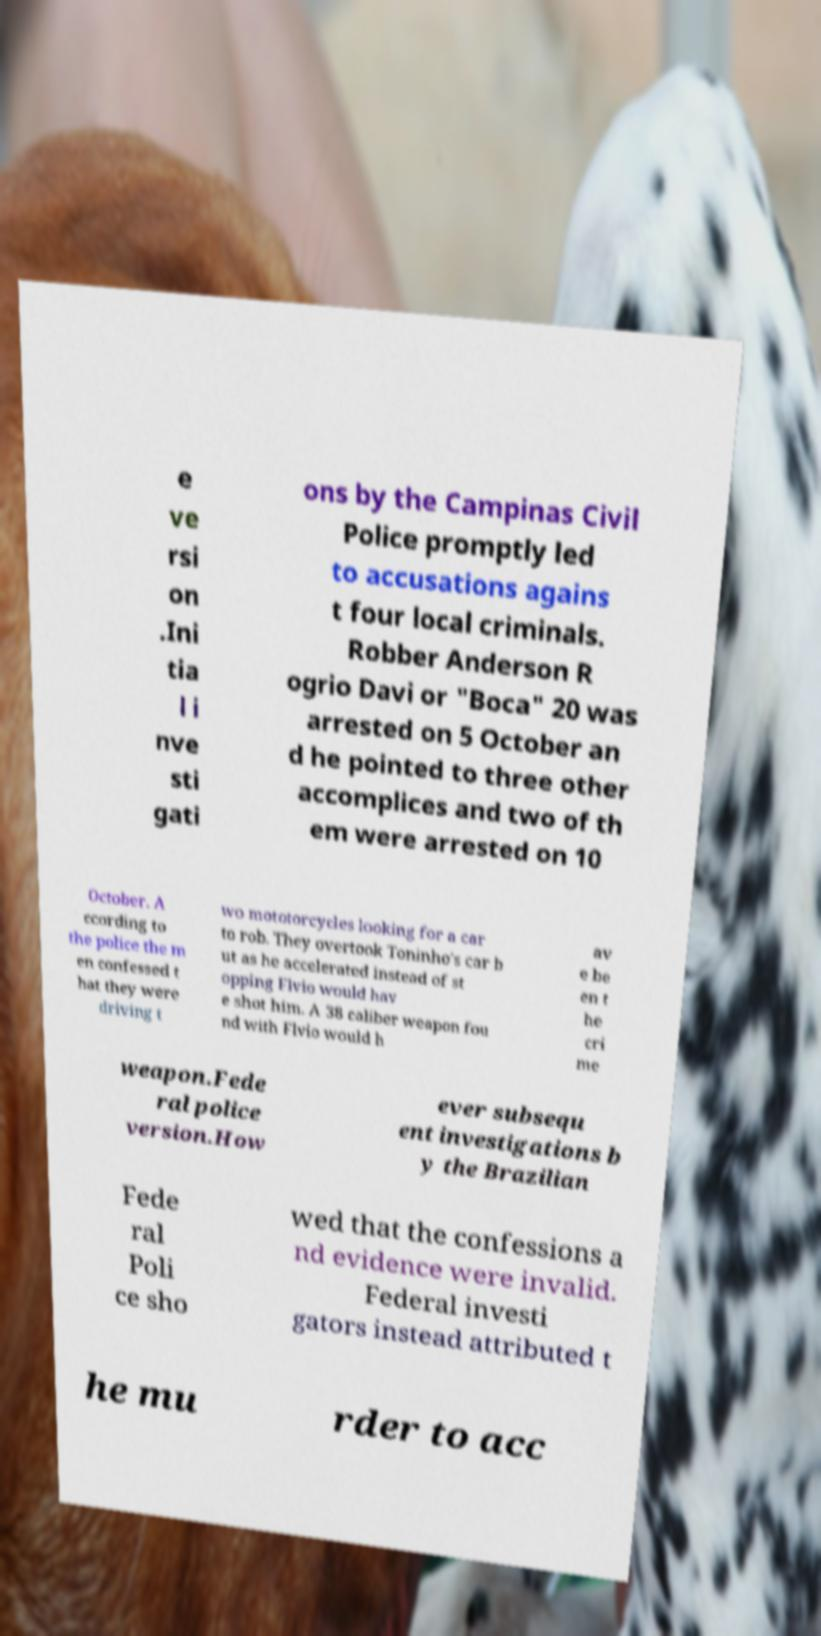I need the written content from this picture converted into text. Can you do that? e ve rsi on .Ini tia l i nve sti gati ons by the Campinas Civil Police promptly led to accusations agains t four local criminals. Robber Anderson R ogrio Davi or "Boca" 20 was arrested on 5 October an d he pointed to three other accomplices and two of th em were arrested on 10 October. A ccording to the police the m en confessed t hat they were driving t wo mototorcycles looking for a car to rob. They overtook Toninho's car b ut as he accelerated instead of st opping Flvio would hav e shot him. A 38 caliber weapon fou nd with Flvio would h av e be en t he cri me weapon.Fede ral police version.How ever subsequ ent investigations b y the Brazilian Fede ral Poli ce sho wed that the confessions a nd evidence were invalid. Federal investi gators instead attributed t he mu rder to acc 